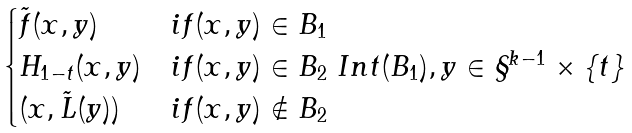<formula> <loc_0><loc_0><loc_500><loc_500>\begin{cases} \tilde { f } ( x , y ) & i f ( x , y ) \in B _ { 1 } \\ H _ { 1 - t } ( x , y ) & i f ( x , y ) \in B _ { 2 } \ I n t ( B _ { 1 } ) , y \in \S ^ { k - 1 } \times \{ t \} \\ ( x , \tilde { L } ( y ) ) & i f ( x , y ) \notin B _ { 2 } \end{cases}</formula> 